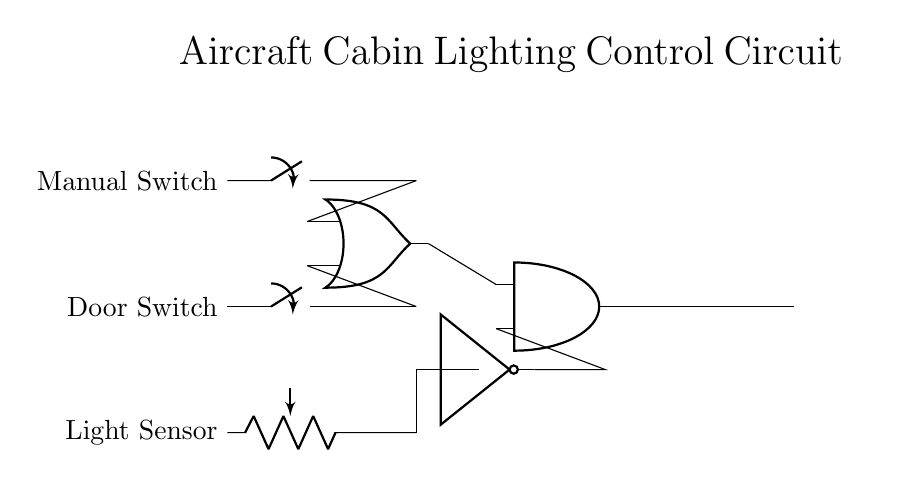What type of component is used to detect light? The circuit includes a light sensor, represented as a component that responds to the surrounding light conditions. It is connected in a way to influence the cabin lights based on detected light levels.
Answer: Light sensor What logical function does the OR gate perform? The OR gate allows cabin lights to be activated if either the door switch or the manual switch is closed. Thus, it provides a logical output that is high if at least one input is high.
Answer: OR How many switches are present in the circuit? There are two switches: a door switch and a manual switch, each allowing operational control over the cabin lights.
Answer: Two switches Which component controls the cabin lights output? The cabin lights are controlled by the output of an AND gate, which requires a specific condition from its inputs to activate the lights.
Answer: AND gate What does the NOT gate do in this circuit? The NOT gate inverts the signal from the light sensor, meaning it allows cabin lights to turn on only when it is dark, indicating that the light sensor is not detecting sufficient light.
Answer: Inverts signal Under what condition will the cabin lights turn on? The cabin lights will turn on if either the door switch or the manual switch is activated, and the light sensor detects a low light condition (inverted signal from the NOT gate).
Answer: Switch activated and light sensor low 